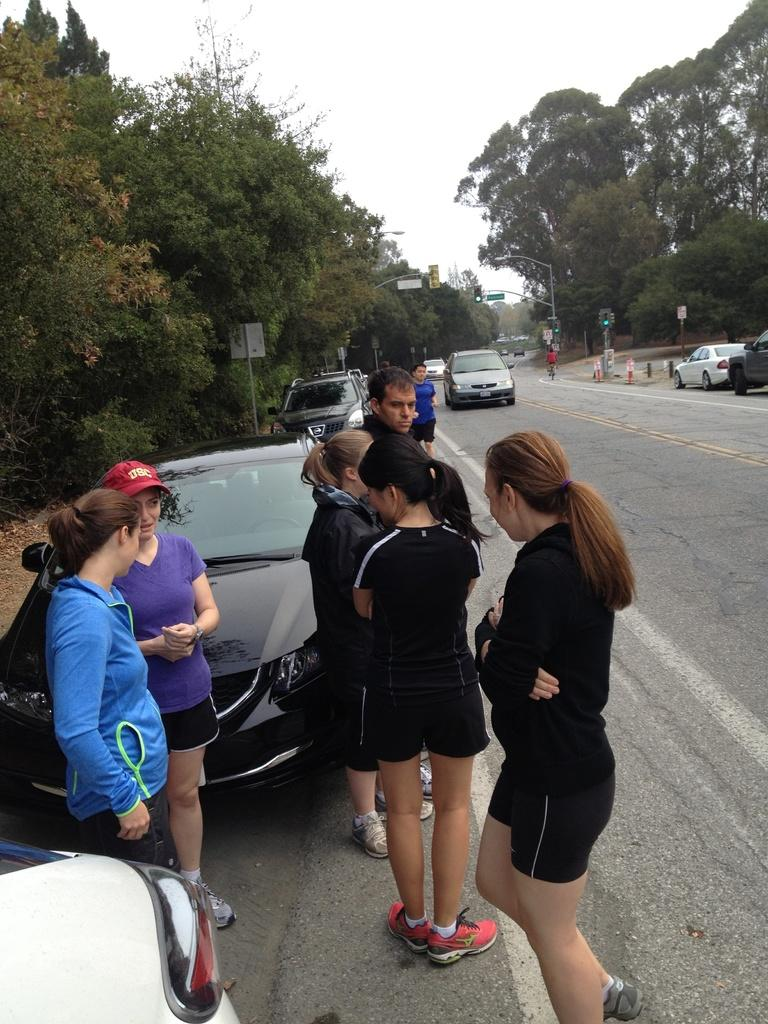Who or what can be seen in the image? There are people and cars in the image. What structures are present in the image? There are light poles in the image. What type of vegetation is visible in the image? There are trees in the image. What type of pathway is present in the image? There is a road in the image. What can be seen in the background of the image? The sky is visible in the background of the image. Can you tell me where the maid is located in the image? There is no maid present in the image. What type of creature can be seen interacting with the people in the image? There is no creature present in the image; only people, cars, light poles, trees, a road, and the sky are visible. 